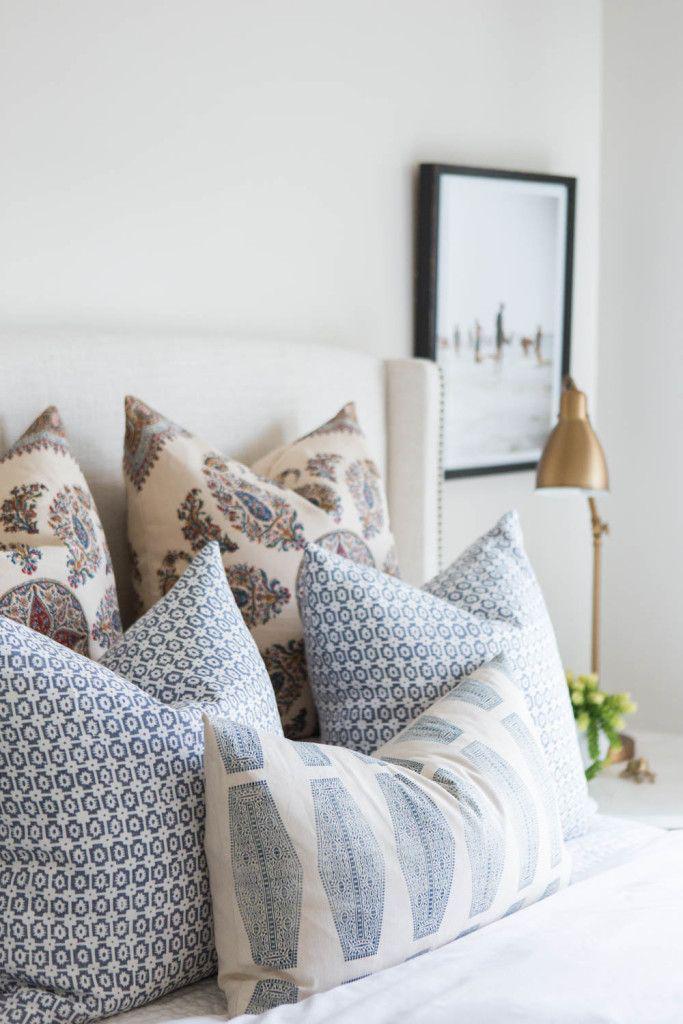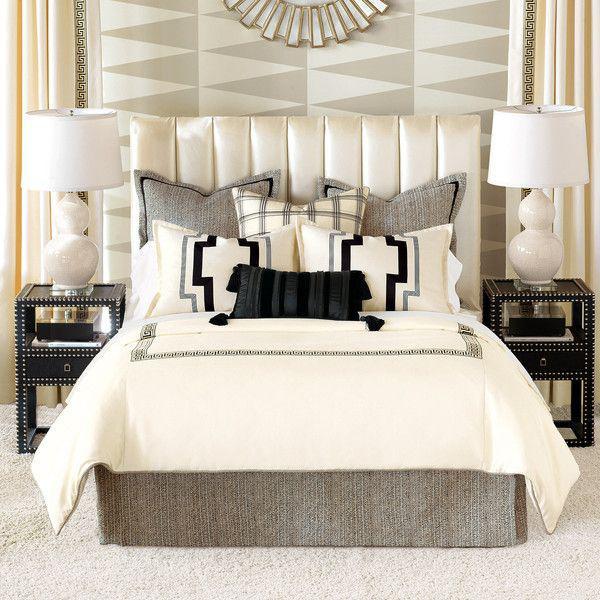The first image is the image on the left, the second image is the image on the right. For the images displayed, is the sentence "On the wall above the headboard of one bed is a round decorative object." factually correct? Answer yes or no. Yes. 